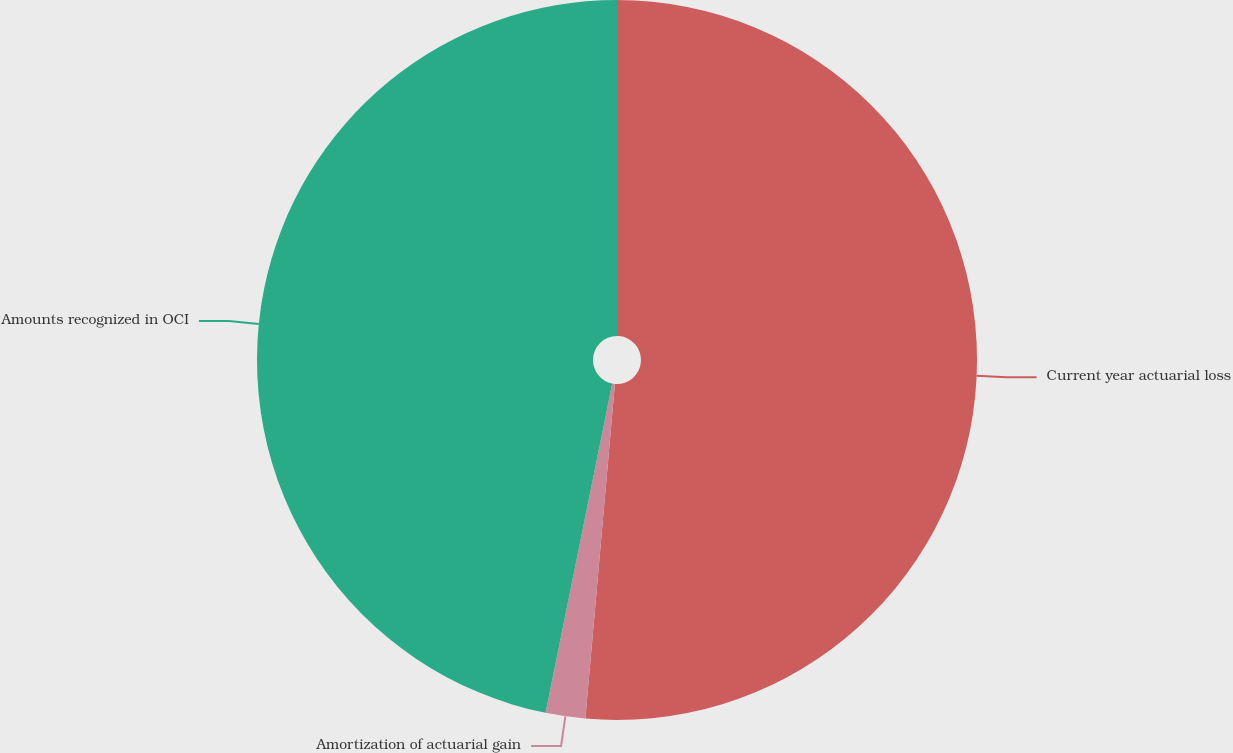Convert chart to OTSL. <chart><loc_0><loc_0><loc_500><loc_500><pie_chart><fcel>Current year actuarial loss<fcel>Amortization of actuarial gain<fcel>Amounts recognized in OCI<nl><fcel>51.4%<fcel>1.78%<fcel>46.82%<nl></chart> 